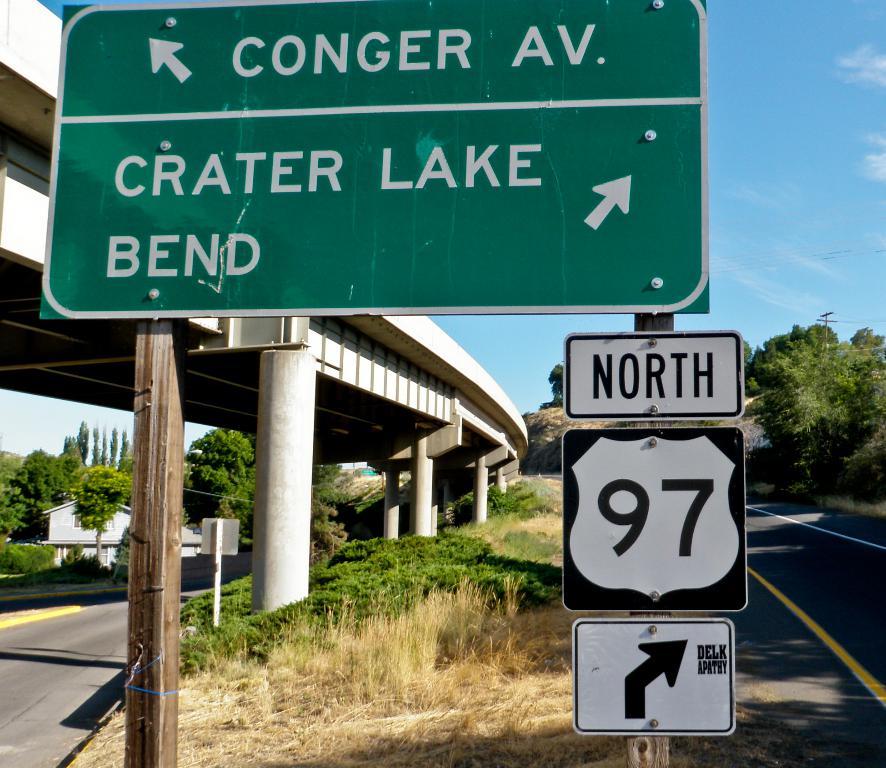What lake is ahead?
Make the answer very short. Crater lake. 